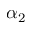Convert formula to latex. <formula><loc_0><loc_0><loc_500><loc_500>\alpha _ { 2 }</formula> 